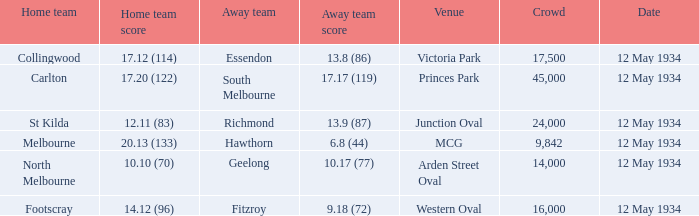What was the home teams score while playing the away team of south melbourne? 17.20 (122). 